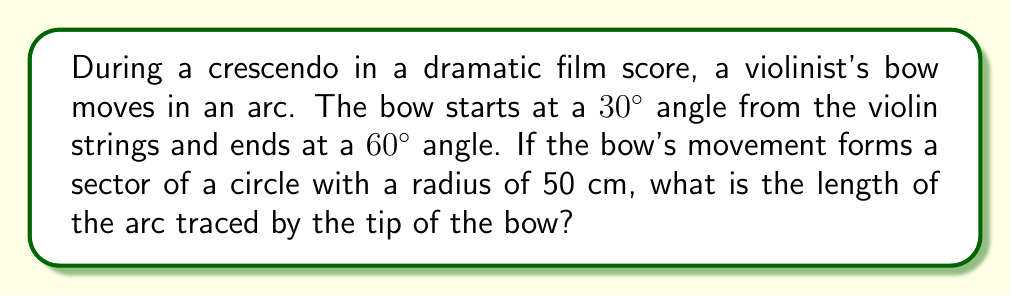Can you solve this math problem? Let's approach this step-by-step:

1) First, we need to determine the central angle of the sector. The bow moves from 30° to 60°, so the central angle is:
   $60° - 30° = 30°$

2) We know that the full circle is 360°. The arc length formula is:
   $$s = \frac{\theta}{360°} \cdot 2\pi r$$
   Where $s$ is the arc length, $\theta$ is the central angle in degrees, and $r$ is the radius.

3) Substituting our values:
   $$s = \frac{30°}{360°} \cdot 2\pi \cdot 50\text{ cm}$$

4) Simplify:
   $$s = \frac{1}{12} \cdot 2\pi \cdot 50\text{ cm}$$
   $$s = \frac{\pi}{6} \cdot 50\text{ cm}$$
   $$s = \frac{50\pi}{6}\text{ cm}$$

5) Calculate:
   $$s \approx 26.18\text{ cm}$$

This arc length represents the dramatic sweep of the bow during the crescendo, evoking the intensity of the musical moment in the film score.
Answer: $\frac{50\pi}{6}\text{ cm}$ or approximately 26.18 cm 